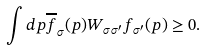<formula> <loc_0><loc_0><loc_500><loc_500>\int d { p } \overline { f } _ { \sigma } ( { p } ) W _ { \sigma \sigma ^ { \prime } } f _ { \sigma ^ { \prime } } ( { p } ) \geq 0 .</formula> 